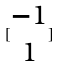<formula> <loc_0><loc_0><loc_500><loc_500>[ \begin{matrix} - 1 \\ 1 \end{matrix} ]</formula> 